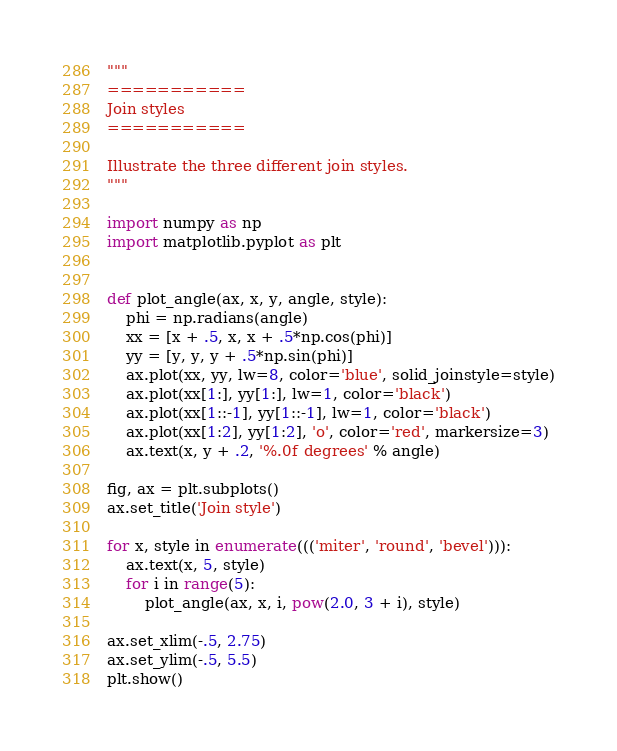<code> <loc_0><loc_0><loc_500><loc_500><_Python_>"""
===========
Join styles
===========

Illustrate the three different join styles.
"""

import numpy as np
import matplotlib.pyplot as plt


def plot_angle(ax, x, y, angle, style):
    phi = np.radians(angle)
    xx = [x + .5, x, x + .5*np.cos(phi)]
    yy = [y, y, y + .5*np.sin(phi)]
    ax.plot(xx, yy, lw=8, color='blue', solid_joinstyle=style)
    ax.plot(xx[1:], yy[1:], lw=1, color='black')
    ax.plot(xx[1::-1], yy[1::-1], lw=1, color='black')
    ax.plot(xx[1:2], yy[1:2], 'o', color='red', markersize=3)
    ax.text(x, y + .2, '%.0f degrees' % angle)

fig, ax = plt.subplots()
ax.set_title('Join style')

for x, style in enumerate((('miter', 'round', 'bevel'))):
    ax.text(x, 5, style)
    for i in range(5):
        plot_angle(ax, x, i, pow(2.0, 3 + i), style)

ax.set_xlim(-.5, 2.75)
ax.set_ylim(-.5, 5.5)
plt.show()
</code> 